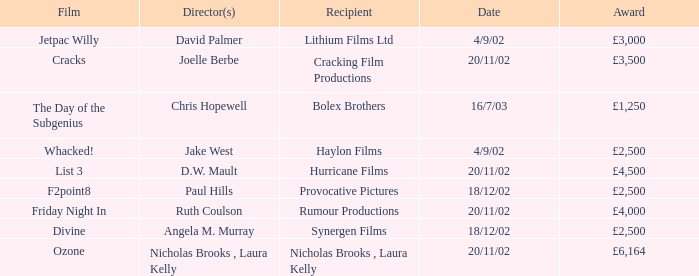What award did the film Ozone win? £6,164. 